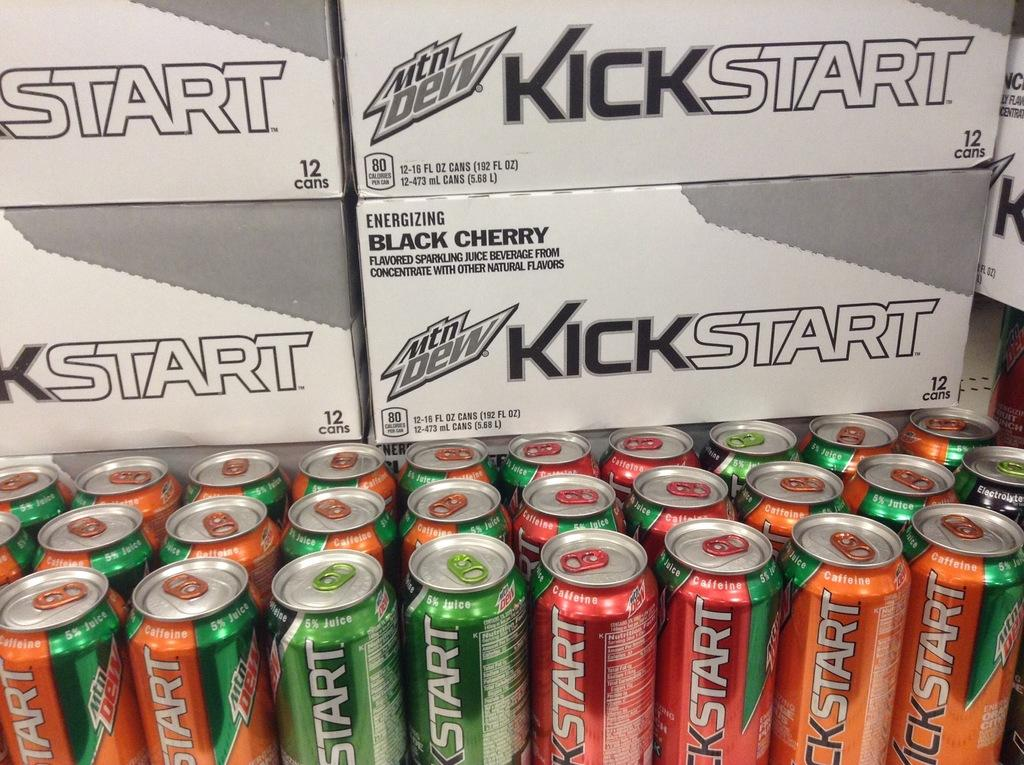<image>
Describe the image concisely. Boxes and cans of a drink called Kickstart. 